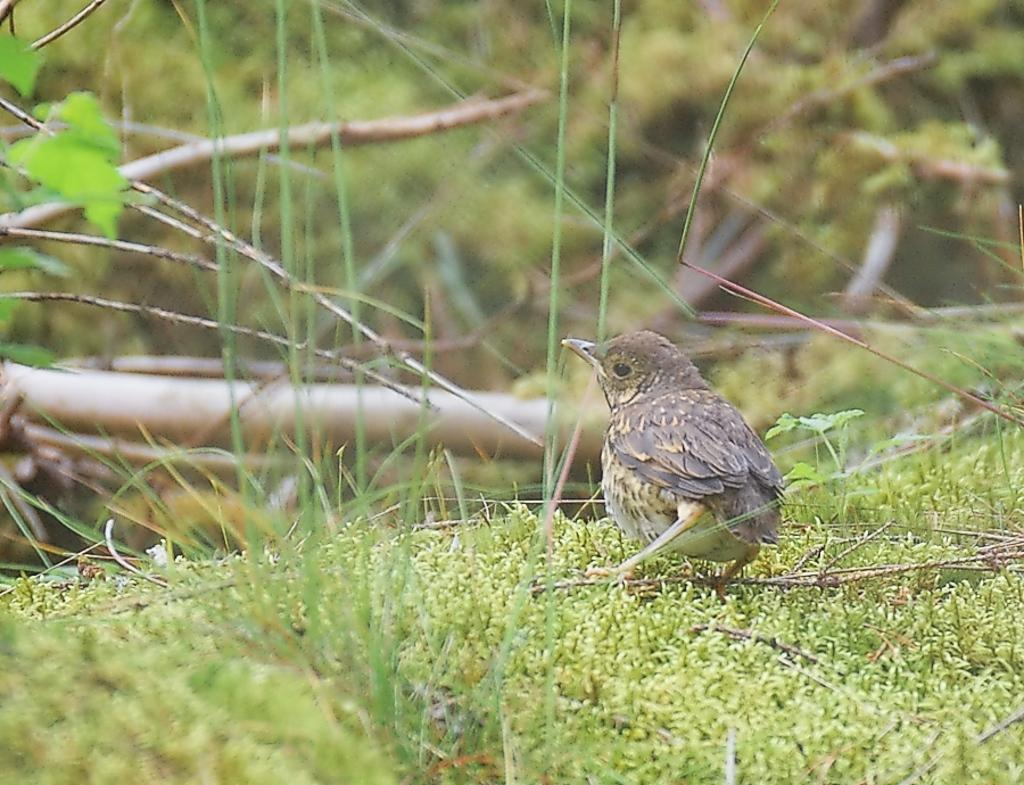What type of animal is in the image? There is a small bird in the image. What is the bird standing on? The bird is standing on the grass. What color is the background of the image? The background of the image is blue. Can you tell me how many kittens are playing with the beetle in the image? There are no kittens or beetles present in the image; it features a small bird standing on the grass with a blue background. 